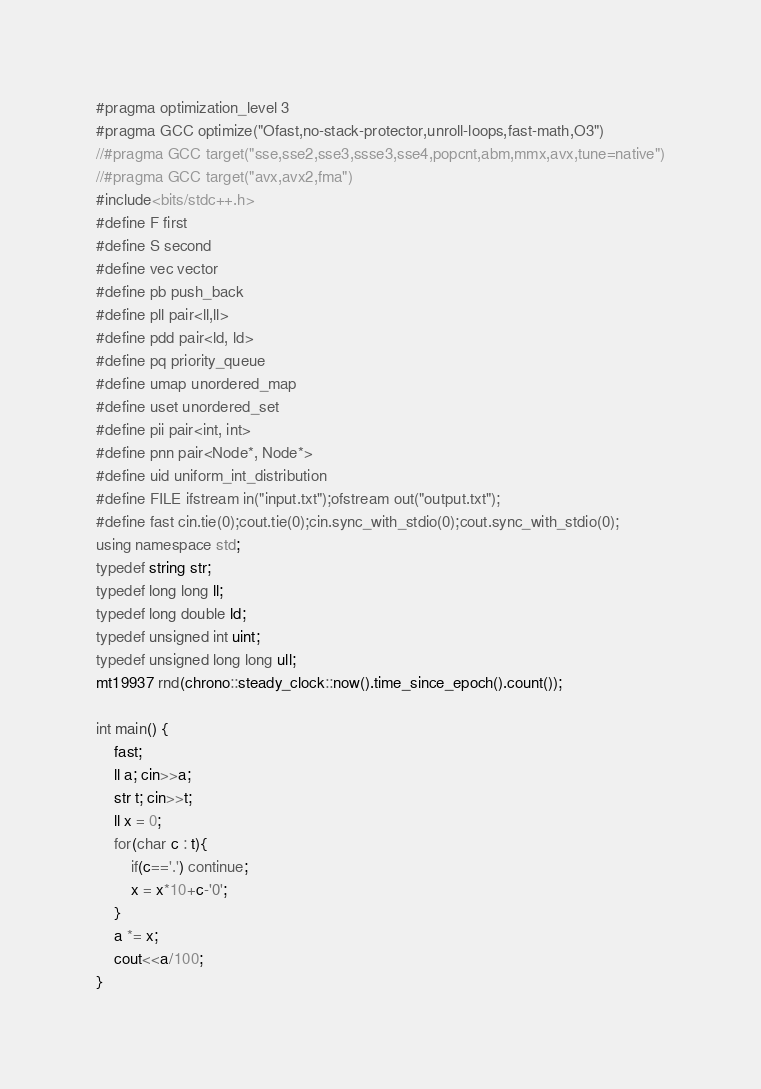<code> <loc_0><loc_0><loc_500><loc_500><_C++_>#pragma optimization_level 3
#pragma GCC optimize("Ofast,no-stack-protector,unroll-loops,fast-math,O3")
//#pragma GCC target("sse,sse2,sse3,ssse3,sse4,popcnt,abm,mmx,avx,tune=native")
//#pragma GCC target("avx,avx2,fma")
#include<bits/stdc++.h>
#define F first
#define S second
#define vec vector
#define pb push_back
#define pll pair<ll,ll>
#define pdd pair<ld, ld>
#define pq priority_queue
#define umap unordered_map
#define uset unordered_set
#define pii pair<int, int>
#define pnn pair<Node*, Node*>
#define uid uniform_int_distribution
#define FILE ifstream in("input.txt");ofstream out("output.txt");
#define fast cin.tie(0);cout.tie(0);cin.sync_with_stdio(0);cout.sync_with_stdio(0);
using namespace std;
typedef string str;
typedef long long ll;
typedef long double ld;
typedef unsigned int uint;
typedef unsigned long long ull;
mt19937 rnd(chrono::steady_clock::now().time_since_epoch().count());

int main() {
    fast;
    ll a; cin>>a;
    str t; cin>>t;
    ll x = 0;
    for(char c : t){
        if(c=='.') continue;
        x = x*10+c-'0';
    }
    a *= x;
    cout<<a/100;
}</code> 